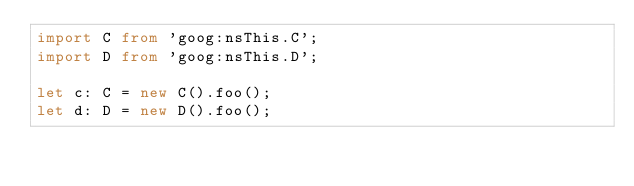Convert code to text. <code><loc_0><loc_0><loc_500><loc_500><_TypeScript_>import C from 'goog:nsThis.C';
import D from 'goog:nsThis.D';

let c: C = new C().foo();
let d: D = new D().foo();</code> 